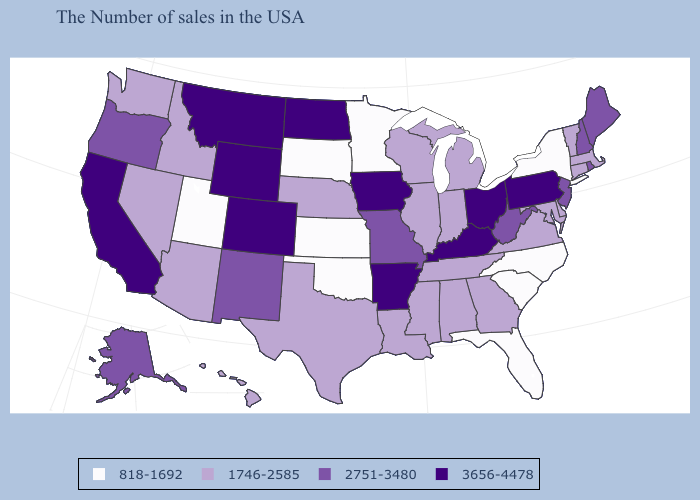How many symbols are there in the legend?
Give a very brief answer. 4. Among the states that border California , does Nevada have the lowest value?
Keep it brief. Yes. Among the states that border Arizona , does Utah have the lowest value?
Concise answer only. Yes. Name the states that have a value in the range 2751-3480?
Keep it brief. Maine, Rhode Island, New Hampshire, New Jersey, West Virginia, Missouri, New Mexico, Oregon, Alaska. Among the states that border Arizona , does California have the highest value?
Short answer required. Yes. What is the value of Maryland?
Answer briefly. 1746-2585. Name the states that have a value in the range 2751-3480?
Give a very brief answer. Maine, Rhode Island, New Hampshire, New Jersey, West Virginia, Missouri, New Mexico, Oregon, Alaska. What is the value of New York?
Quick response, please. 818-1692. Name the states that have a value in the range 818-1692?
Answer briefly. New York, North Carolina, South Carolina, Florida, Minnesota, Kansas, Oklahoma, South Dakota, Utah. Which states have the lowest value in the USA?
Short answer required. New York, North Carolina, South Carolina, Florida, Minnesota, Kansas, Oklahoma, South Dakota, Utah. What is the lowest value in states that border Florida?
Concise answer only. 1746-2585. How many symbols are there in the legend?
Write a very short answer. 4. Which states have the lowest value in the USA?
Be succinct. New York, North Carolina, South Carolina, Florida, Minnesota, Kansas, Oklahoma, South Dakota, Utah. What is the highest value in the USA?
Answer briefly. 3656-4478. What is the value of New York?
Short answer required. 818-1692. 